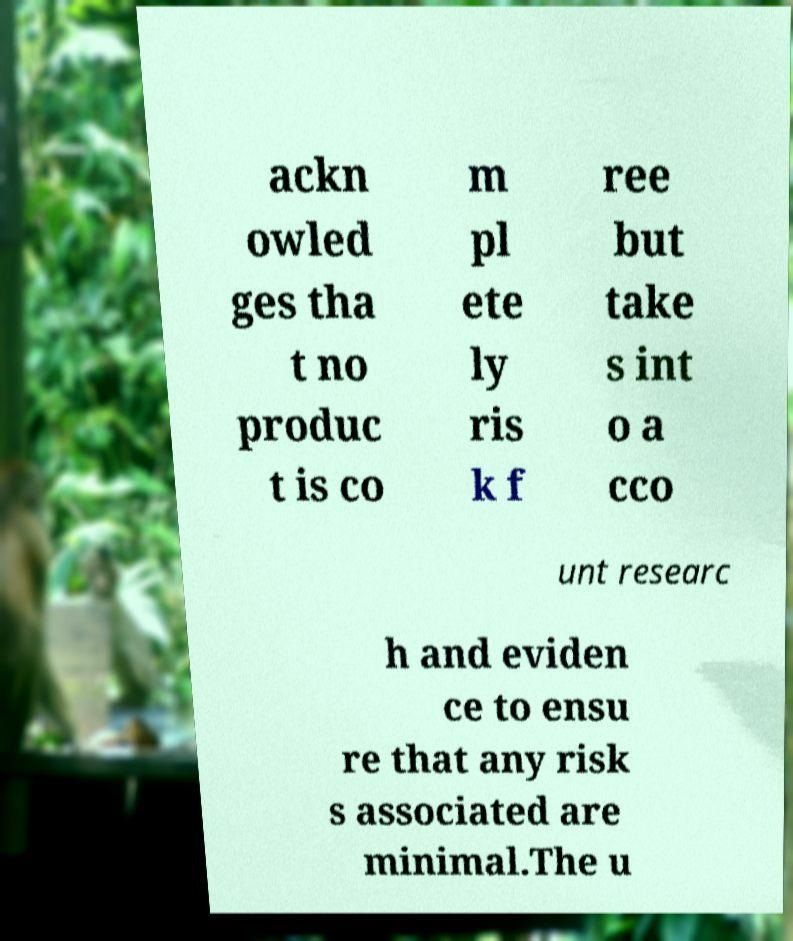Please read and relay the text visible in this image. What does it say? ackn owled ges tha t no produc t is co m pl ete ly ris k f ree but take s int o a cco unt researc h and eviden ce to ensu re that any risk s associated are minimal.The u 